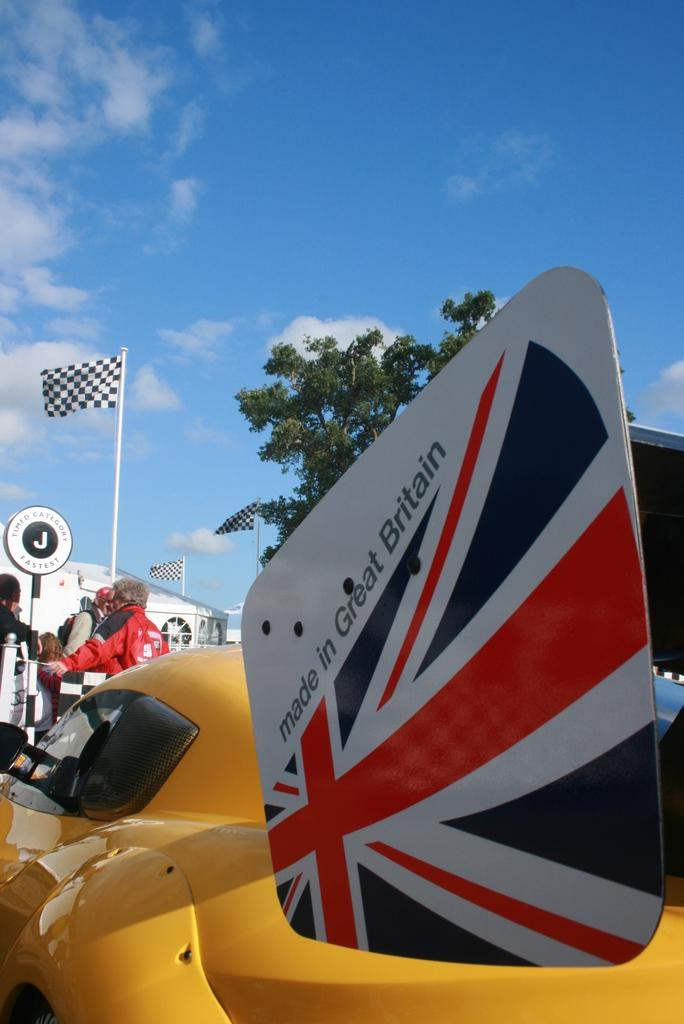<image>
Present a compact description of the photo's key features. a sign behind a sort of vehicle that says 'made in great britain' 